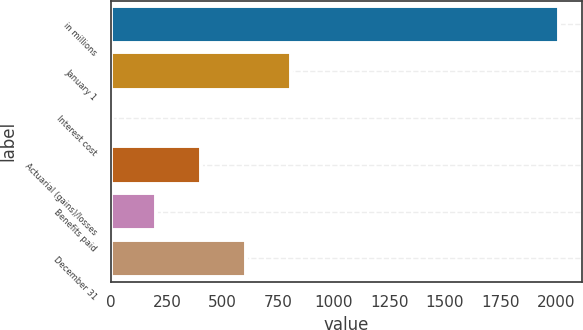Convert chart to OTSL. <chart><loc_0><loc_0><loc_500><loc_500><bar_chart><fcel>in millions<fcel>January 1<fcel>Interest cost<fcel>Actuarial (gains)/losses<fcel>Benefits paid<fcel>December 31<nl><fcel>2014<fcel>806.68<fcel>1.8<fcel>404.24<fcel>203.02<fcel>605.46<nl></chart> 